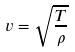<formula> <loc_0><loc_0><loc_500><loc_500>v = \sqrt { \frac { T } { \rho } }</formula> 